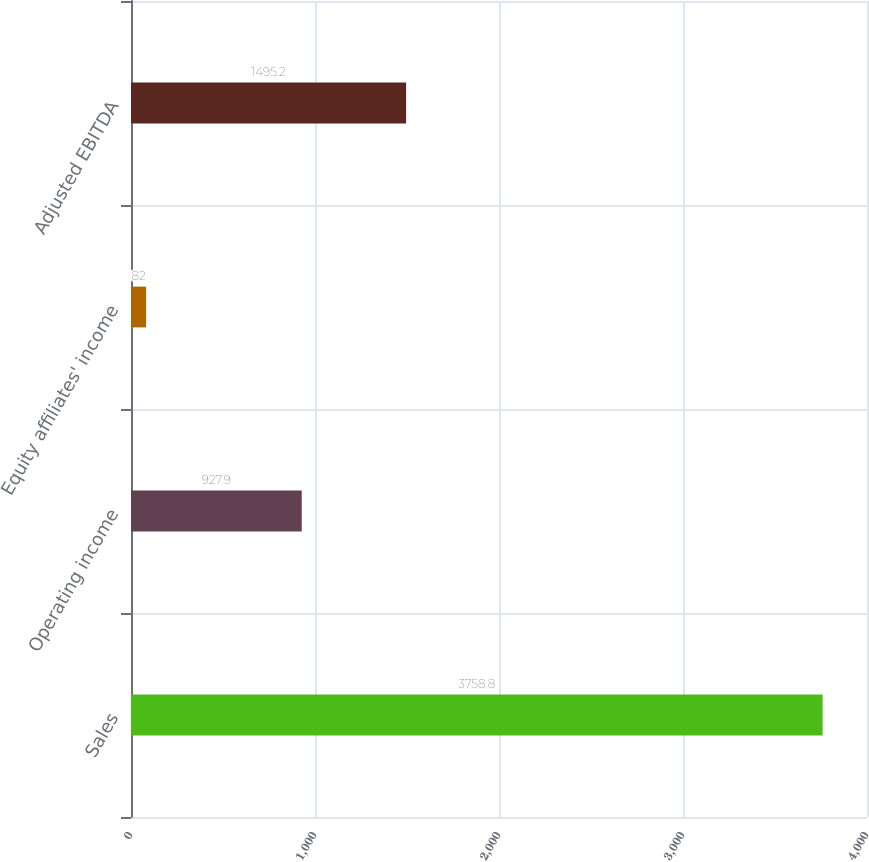Convert chart to OTSL. <chart><loc_0><loc_0><loc_500><loc_500><bar_chart><fcel>Sales<fcel>Operating income<fcel>Equity affiliates' income<fcel>Adjusted EBITDA<nl><fcel>3758.8<fcel>927.9<fcel>82<fcel>1495.2<nl></chart> 